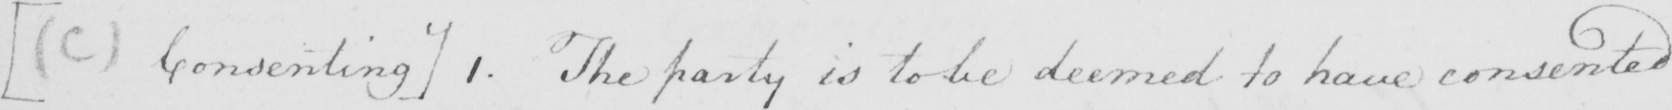What text is written in this handwritten line? [  ( C )  Consenting ]  1 . The party is to be deemed to have consented 